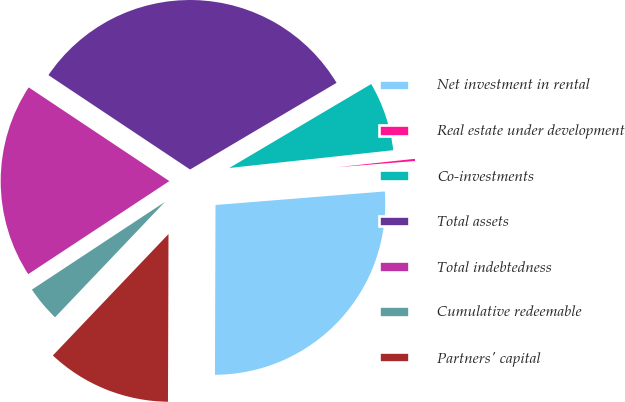Convert chart. <chart><loc_0><loc_0><loc_500><loc_500><pie_chart><fcel>Net investment in rental<fcel>Real estate under development<fcel>Co-investments<fcel>Total assets<fcel>Total indebtedness<fcel>Cumulative redeemable<fcel>Partners' capital<nl><fcel>26.32%<fcel>0.45%<fcel>6.78%<fcel>32.14%<fcel>18.63%<fcel>3.61%<fcel>12.06%<nl></chart> 